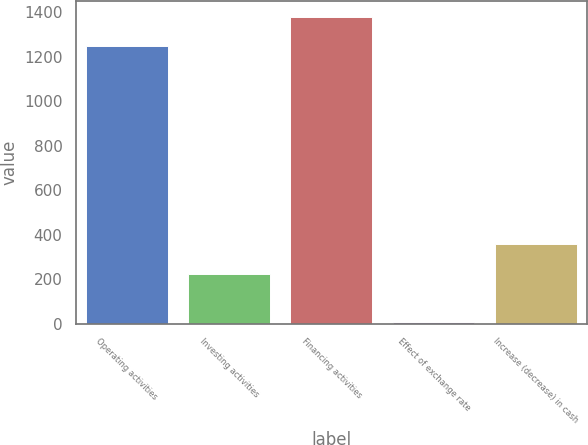<chart> <loc_0><loc_0><loc_500><loc_500><bar_chart><fcel>Operating activities<fcel>Investing activities<fcel>Financing activities<fcel>Effect of exchange rate<fcel>Increase (decrease) in cash<nl><fcel>1246<fcel>225<fcel>1379.8<fcel>6<fcel>358.8<nl></chart> 